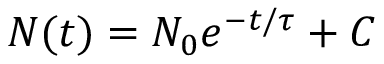<formula> <loc_0><loc_0><loc_500><loc_500>N ( t ) = N _ { 0 } e ^ { - t / \tau } + C</formula> 